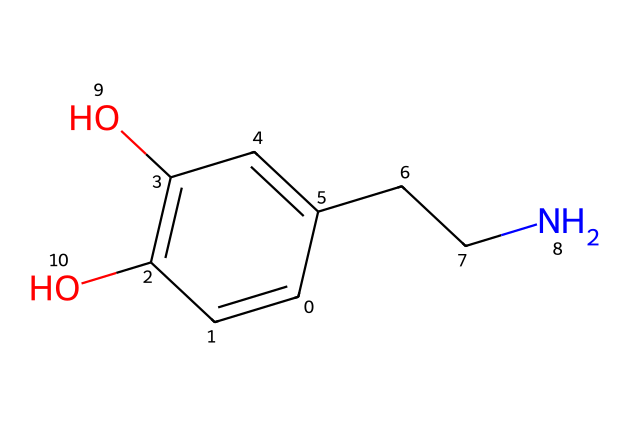What is the primary functional group present in this chemical? The chemical structure contains hydroxyl groups (-OH) indicated by the oxygen atoms attached to carbon in the benzene ring. These functional groups are responsible for its alcohol properties.
Answer: hydroxyl How many carbon atoms are in this chemical? By counting the carbon atoms from the skeleton structure represented in the SMILES, we determine there are 11 carbon atoms total in the structure.
Answer: 11 Which atom connects the alkyl chain to the aromatic ring? The alkyl chain (CCN) connects to the aromatic ring through a carbon atom (the Chain-Carbon). This further emphasizes the structure's link to its functional properties influenced by both the aromatic and aliphatic portions.
Answer: carbon Does this chemical indicate a potential for water solubility? The presence of hydroxyl groups suggests that this chemical may be water-soluble due to the ability of -OH groups to form hydrogen bonds with water molecules.
Answer: yes What type of drug classification does this chemical most likely belong to? Given the structural features, including aromatic and amine components, this compound is likely classified as a psychoactive or mood-regulating drug, commonly found in discussions about neurotransmission.
Answer: psychoactive 